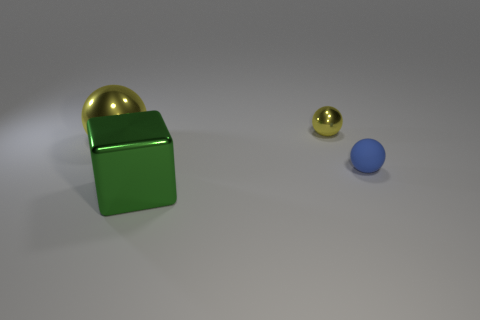Add 3 tiny blue matte things. How many objects exist? 7 Subtract all tiny yellow shiny spheres. How many spheres are left? 2 Subtract all gray blocks. How many blue spheres are left? 1 Subtract all green metallic balls. Subtract all large green things. How many objects are left? 3 Add 4 spheres. How many spheres are left? 7 Add 3 small blue rubber things. How many small blue rubber things exist? 4 Subtract all yellow balls. How many balls are left? 1 Subtract 0 cyan cylinders. How many objects are left? 4 Subtract all blocks. How many objects are left? 3 Subtract 3 spheres. How many spheres are left? 0 